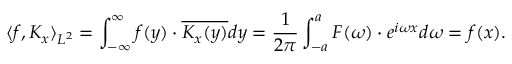Convert formula to latex. <formula><loc_0><loc_0><loc_500><loc_500>\langle f , K _ { x } \rangle _ { L ^ { 2 } } = \int _ { - \infty } ^ { \infty } f ( y ) \cdot { \overline { { K _ { x } ( y ) } } } d y = { \frac { 1 } { 2 \pi } } \int _ { - a } ^ { a } F ( \omega ) \cdot e ^ { i \omega x } d \omega = f ( x ) .</formula> 